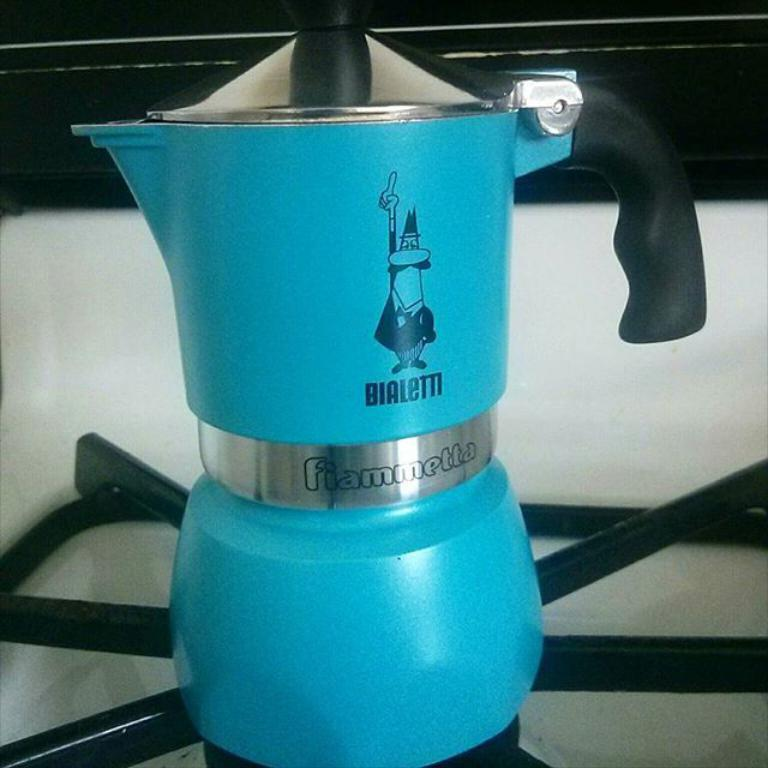Provide a one-sentence caption for the provided image. A blue kettle with BIALETTI written on the side. 